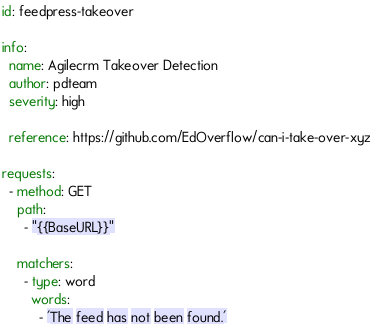<code> <loc_0><loc_0><loc_500><loc_500><_YAML_>id: feedpress-takeover

info:
  name: Agilecrm Takeover Detection
  author: pdteam
  severity: high
 
  reference: https://github.com/EdOverflow/can-i-take-over-xyz

requests:
  - method: GET
    path:
      - "{{BaseURL}}"

    matchers:
      - type: word
        words:
          - 'The feed has not been found.'</code> 